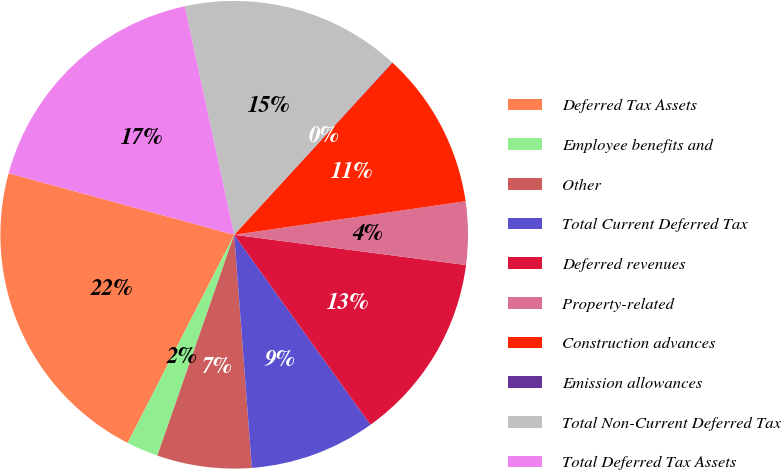Convert chart to OTSL. <chart><loc_0><loc_0><loc_500><loc_500><pie_chart><fcel>Deferred Tax Assets<fcel>Employee benefits and<fcel>Other<fcel>Total Current Deferred Tax<fcel>Deferred revenues<fcel>Property-related<fcel>Construction advances<fcel>Emission allowances<fcel>Total Non-Current Deferred Tax<fcel>Total Deferred Tax Assets<nl><fcel>21.71%<fcel>2.2%<fcel>6.53%<fcel>8.7%<fcel>13.03%<fcel>4.36%<fcel>10.87%<fcel>0.03%<fcel>15.2%<fcel>17.37%<nl></chart> 